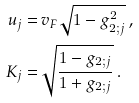Convert formula to latex. <formula><loc_0><loc_0><loc_500><loc_500>u _ { j } = & \, v _ { F } \sqrt { 1 - g _ { 2 ; j } ^ { 2 } } \, , \\ K _ { j } = & \, \sqrt { \frac { 1 - g _ { 2 ; j } } { 1 + g _ { 2 ; j } } } \, .</formula> 